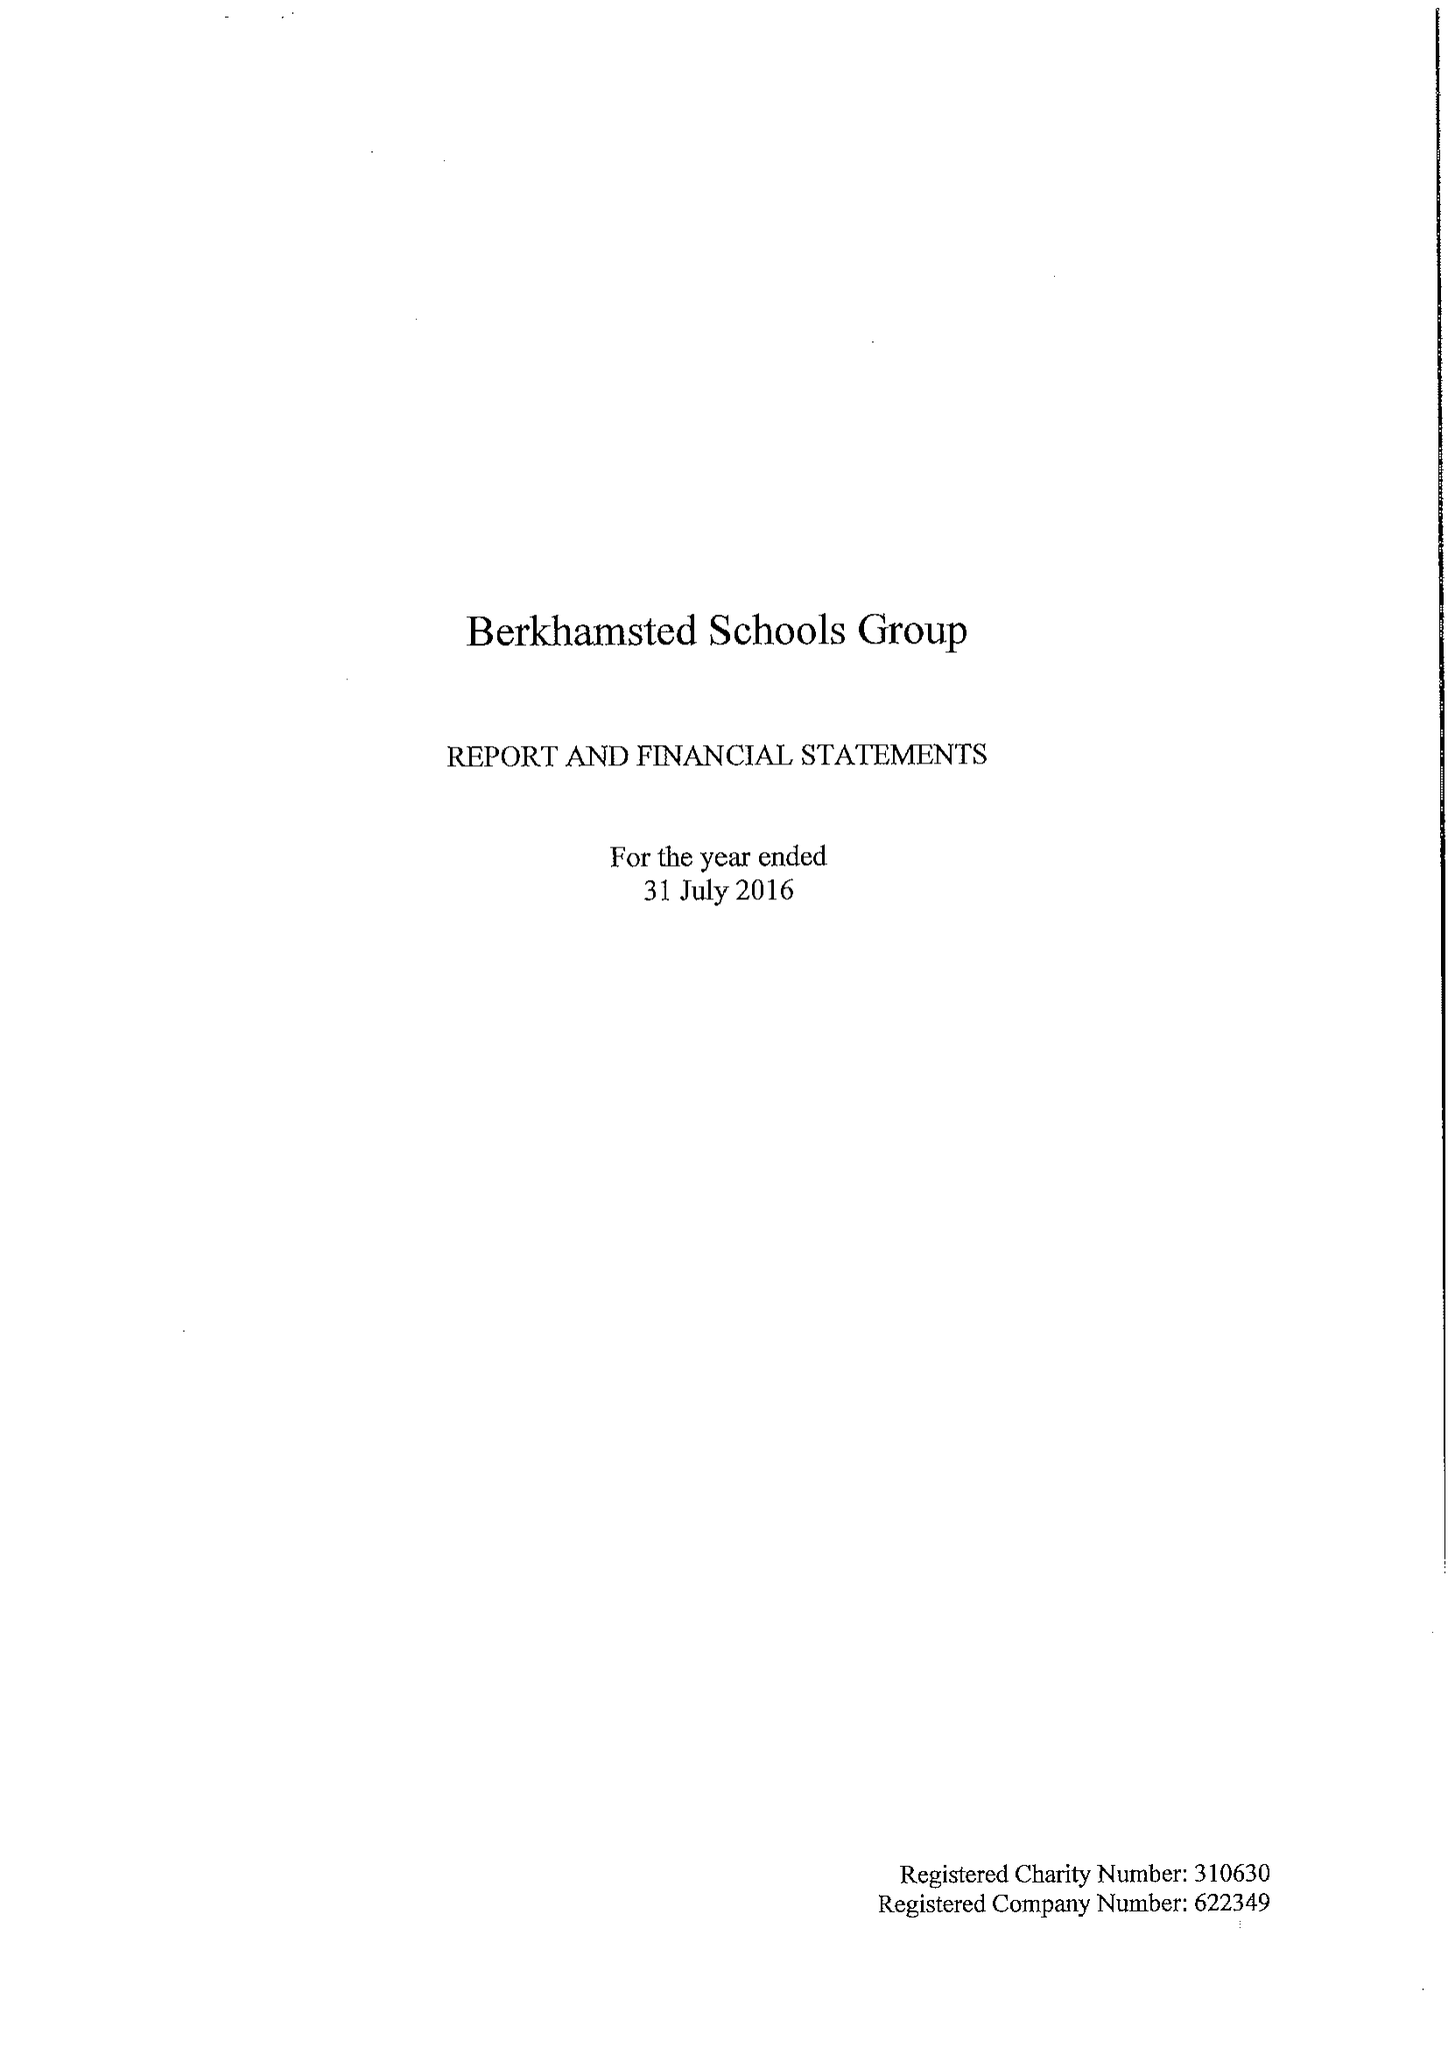What is the value for the charity_number?
Answer the question using a single word or phrase. 310630 